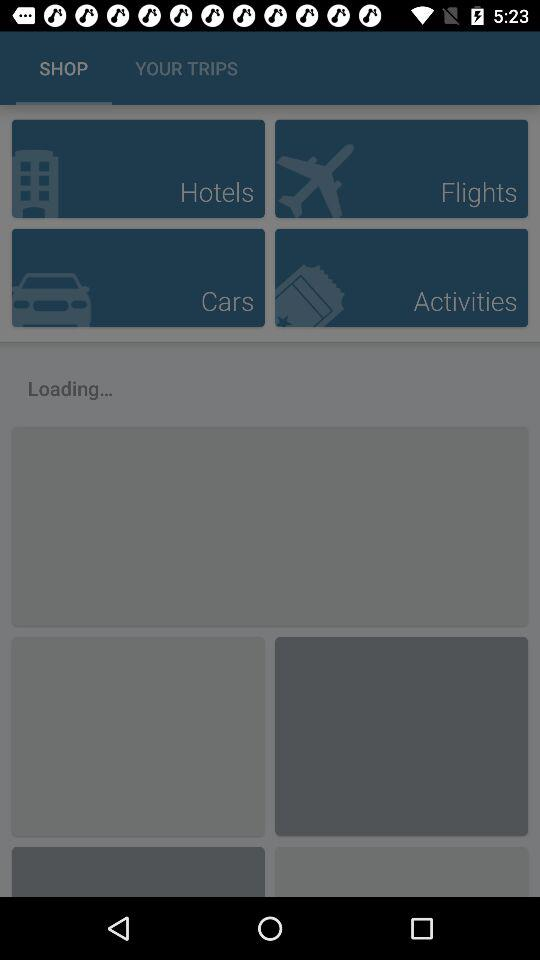Which tab has been selected? The selected tab is "SHOP". 